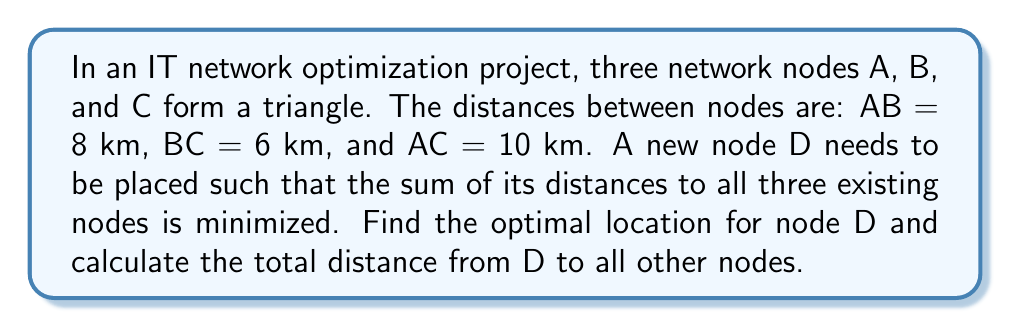Can you answer this question? To solve this problem, we'll use the concept of the Fermat point in triangulation, which minimizes the total distance to all vertices of a triangle. Here's the step-by-step solution:

1. First, we need to check if any angle in the triangle is greater than or equal to 120°. If so, the Fermat point would be at that vertex.

2. To check the angles, we can use the cosine law:
   $$\cos A = \frac{b^2 + c^2 - a^2}{2bc}$$

   For angle A: $$\cos A = \frac{6^2 + 10^2 - 8^2}{2 \cdot 6 \cdot 10} = 0.7$$
   $$A = \arccos(0.7) \approx 45.6°$$

   Similarly, we can calculate angles B and C. They are all less than 120°.

3. Since no angle is ≥120°, we need to find the Fermat point inside the triangle. We can use the following formula to calculate the distances from the Fermat point to each vertex:

   $$r = \frac{abc}{a+b+c}$$

   Where a, b, and c are the side lengths of the triangle, and r is the distance from the Fermat point to each vertex.

4. Substituting the values:
   $$r = \frac{8 \cdot 6 \cdot 10}{8 + 6 + 10} = \frac{480}{24} = 20$$

5. The optimal location for node D is the Fermat point of the triangle.

6. The total distance from D to all other nodes is:
   $$\text{Total distance} = 3r = 3 \cdot 20 = 60\text{ km}$$

[asy]
unitsize(0.5cm);
pair A = (0,0), B = (8,0), C = (4,6);
pair D = (4,2.3094);  // Approximate location of Fermat point
draw(A--B--C--cycle);
draw(D--A, dashed);
draw(D--B, dashed);
draw(D--C, dashed);
dot("A", A, SW);
dot("B", B, SE);
dot("C", C, N);
dot("D", D, E);
label("8 km", (A+B)/2, S);
label("6 km", (B+C)/2, NE);
label("10 km", (A+C)/2, NW);
[/asy]
Answer: Optimal location: Fermat point of triangle ABC; Total distance: 60 km 